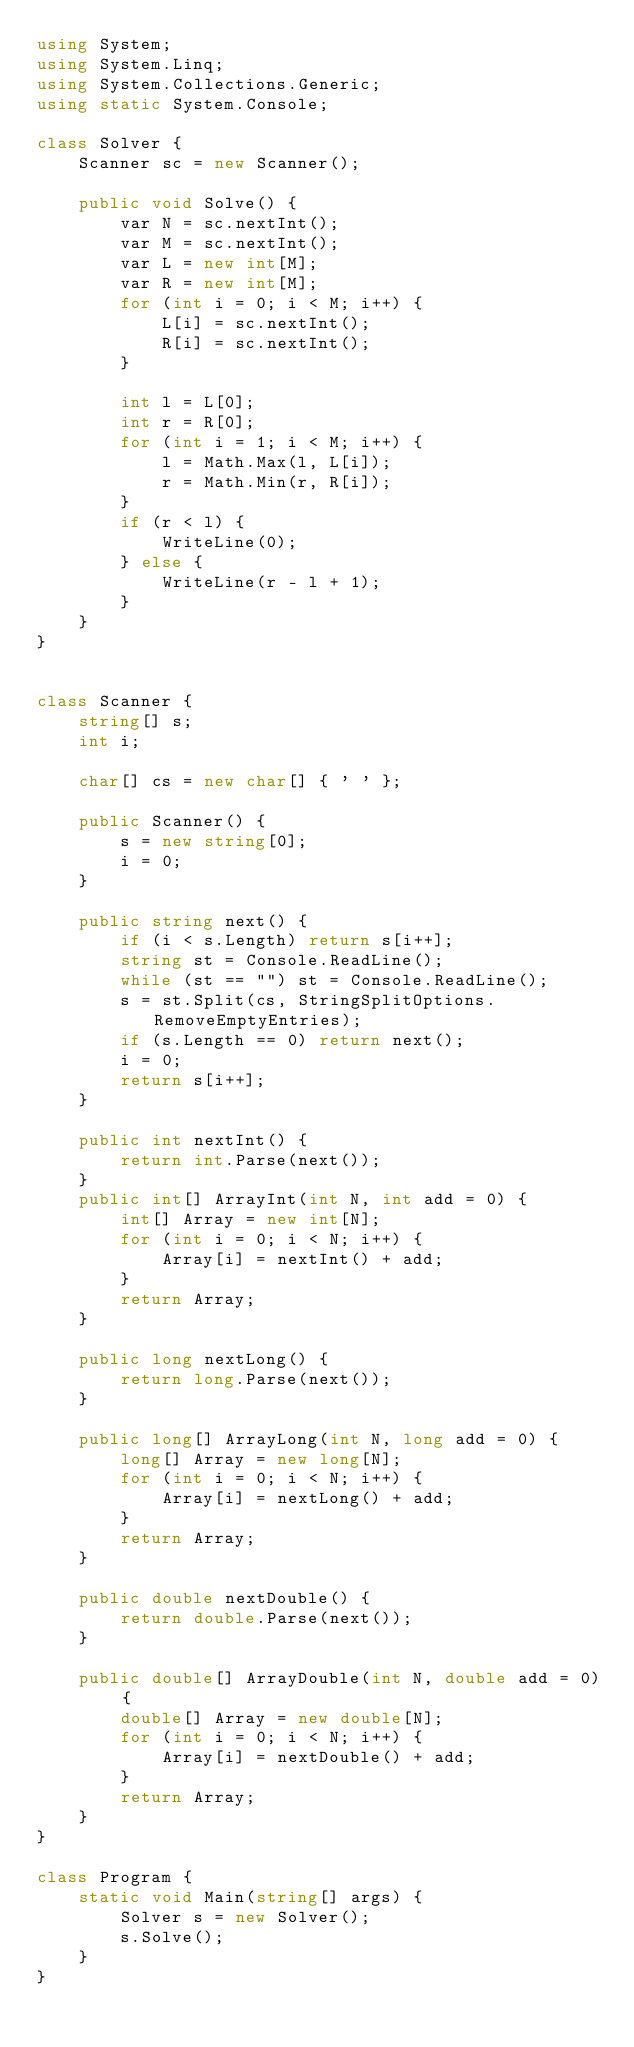Convert code to text. <code><loc_0><loc_0><loc_500><loc_500><_C#_>using System;
using System.Linq;
using System.Collections.Generic;
using static System.Console;

class Solver {
    Scanner sc = new Scanner();
   
    public void Solve() {
        var N = sc.nextInt();
        var M = sc.nextInt();
        var L = new int[M];
        var R = new int[M];
        for (int i = 0; i < M; i++) {
            L[i] = sc.nextInt();
            R[i] = sc.nextInt();
        }

        int l = L[0];
        int r = R[0];
        for (int i = 1; i < M; i++) {
            l = Math.Max(l, L[i]);
            r = Math.Min(r, R[i]);
        }
        if (r < l) {
            WriteLine(0);
        } else {
            WriteLine(r - l + 1);
        }
    }
}


class Scanner {
    string[] s;
    int i;

    char[] cs = new char[] { ' ' };

    public Scanner() {
        s = new string[0];
        i = 0;
    }

    public string next() {
        if (i < s.Length) return s[i++];
        string st = Console.ReadLine();
        while (st == "") st = Console.ReadLine();
        s = st.Split(cs, StringSplitOptions.RemoveEmptyEntries);
        if (s.Length == 0) return next();
        i = 0;
        return s[i++];
    }

    public int nextInt() {
        return int.Parse(next());
    }
    public int[] ArrayInt(int N, int add = 0) {
        int[] Array = new int[N];
        for (int i = 0; i < N; i++) {
            Array[i] = nextInt() + add;
        }
        return Array;
    }

    public long nextLong() {
        return long.Parse(next());
    }

    public long[] ArrayLong(int N, long add = 0) {
        long[] Array = new long[N];
        for (int i = 0; i < N; i++) {
            Array[i] = nextLong() + add;
        }
        return Array;
    }

    public double nextDouble() {
        return double.Parse(next());
    }

    public double[] ArrayDouble(int N, double add = 0) {
        double[] Array = new double[N];
        for (int i = 0; i < N; i++) {
            Array[i] = nextDouble() + add;
        }
        return Array;
    }
}

class Program {
    static void Main(string[] args) {
        Solver s = new Solver();
        s.Solve();
    }
}
</code> 